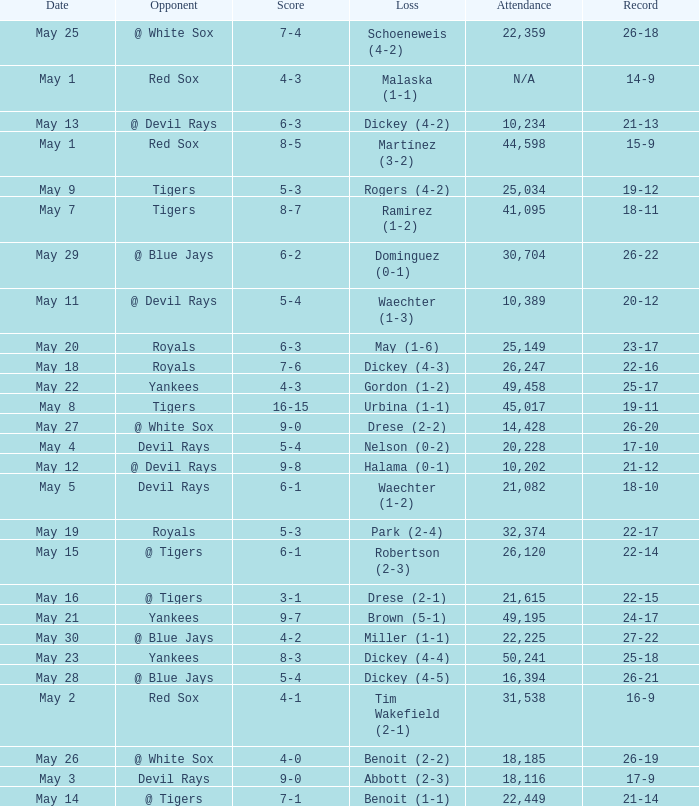What was the score of the game that had a loss of Drese (2-2)? 9-0. 